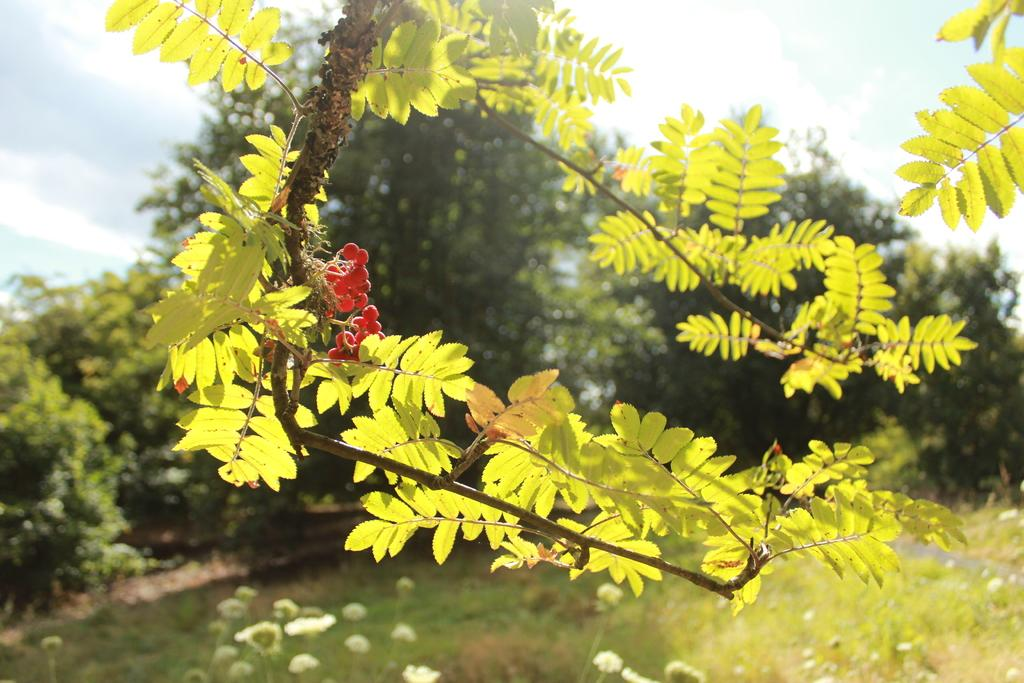What type of vegetation can be seen in the image? There are trees, grass, flowers, and plants visible in the image. What is the surface on which the vegetation is growing? The ground is visible in the image. What else can be seen in the sky in the image? The sky is visible in the image. What type of square is depicted on the page in the image? There is no square or page present in the image; it features trees, grass, flowers, plants, the ground, and the sky. Can you tell me how many chickens are visible in the image? There are no chickens present in the image. 